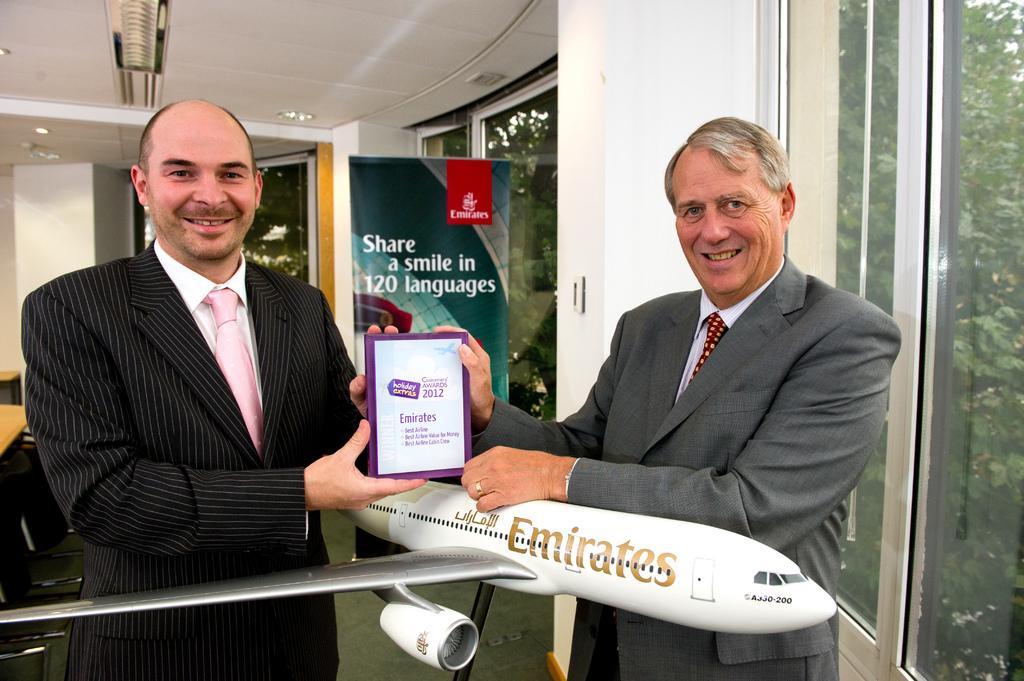Could you give a brief overview of what you see in this image? In this picture I can see 2 men standing in front and I see that, they're holding a thing in their hands and I see something is written on it and I see that they're wearing suits. I can also see a depiction of an aeroplane in front. In the background I can see a board, on which there is something written and I can see the windows on the right side of this picture and through the windows I can see the trees. 